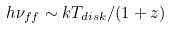<formula> <loc_0><loc_0><loc_500><loc_500>h \nu _ { f f } \sim k T _ { d i s k } / ( 1 + z )</formula> 